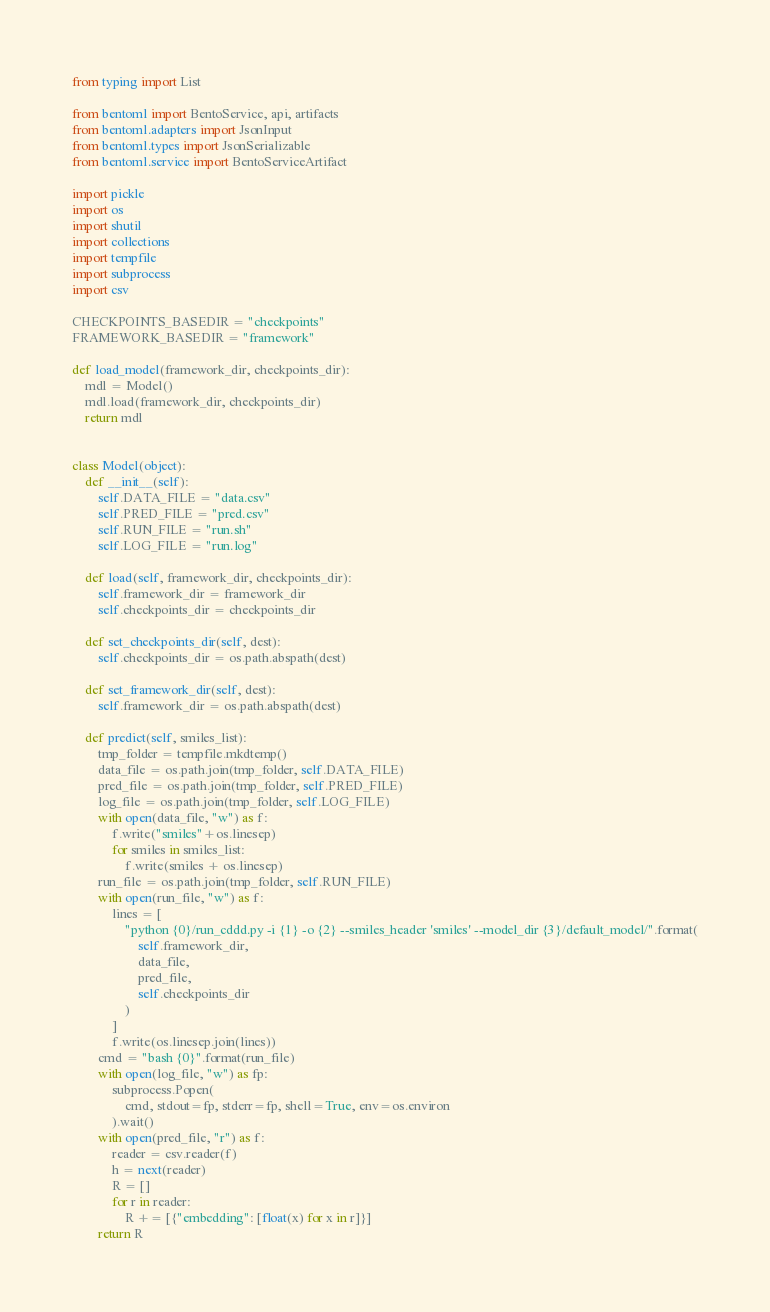<code> <loc_0><loc_0><loc_500><loc_500><_Python_>from typing import List

from bentoml import BentoService, api, artifacts
from bentoml.adapters import JsonInput
from bentoml.types import JsonSerializable
from bentoml.service import BentoServiceArtifact

import pickle
import os
import shutil
import collections
import tempfile
import subprocess
import csv

CHECKPOINTS_BASEDIR = "checkpoints"
FRAMEWORK_BASEDIR = "framework"

def load_model(framework_dir, checkpoints_dir):
    mdl = Model()
    mdl.load(framework_dir, checkpoints_dir)
    return mdl


class Model(object):
    def __init__(self):
        self.DATA_FILE = "data.csv"
        self.PRED_FILE = "pred.csv"
        self.RUN_FILE = "run.sh"
        self.LOG_FILE = "run.log"

    def load(self, framework_dir, checkpoints_dir):
        self.framework_dir = framework_dir
        self.checkpoints_dir = checkpoints_dir

    def set_checkpoints_dir(self, dest):
        self.checkpoints_dir = os.path.abspath(dest)

    def set_framework_dir(self, dest):
        self.framework_dir = os.path.abspath(dest)

    def predict(self, smiles_list):
        tmp_folder = tempfile.mkdtemp()
        data_file = os.path.join(tmp_folder, self.DATA_FILE)
        pred_file = os.path.join(tmp_folder, self.PRED_FILE)
        log_file = os.path.join(tmp_folder, self.LOG_FILE)
        with open(data_file, "w") as f:
            f.write("smiles"+os.linesep)
            for smiles in smiles_list:
                f.write(smiles + os.linesep)
        run_file = os.path.join(tmp_folder, self.RUN_FILE)
        with open(run_file, "w") as f:
            lines = [
                "python {0}/run_cddd.py -i {1} -o {2} --smiles_header 'smiles' --model_dir {3}/default_model/".format(
                    self.framework_dir,
                    data_file,
                    pred_file,
                    self.checkpoints_dir
                )
            ]
            f.write(os.linesep.join(lines))
        cmd = "bash {0}".format(run_file)
        with open(log_file, "w") as fp:
            subprocess.Popen(
                cmd, stdout=fp, stderr=fp, shell=True, env=os.environ
            ).wait()
        with open(pred_file, "r") as f:
            reader = csv.reader(f)
            h = next(reader)
            R = []
            for r in reader:
                R += [{"embedding": [float(x) for x in r]}]
        return R

</code> 